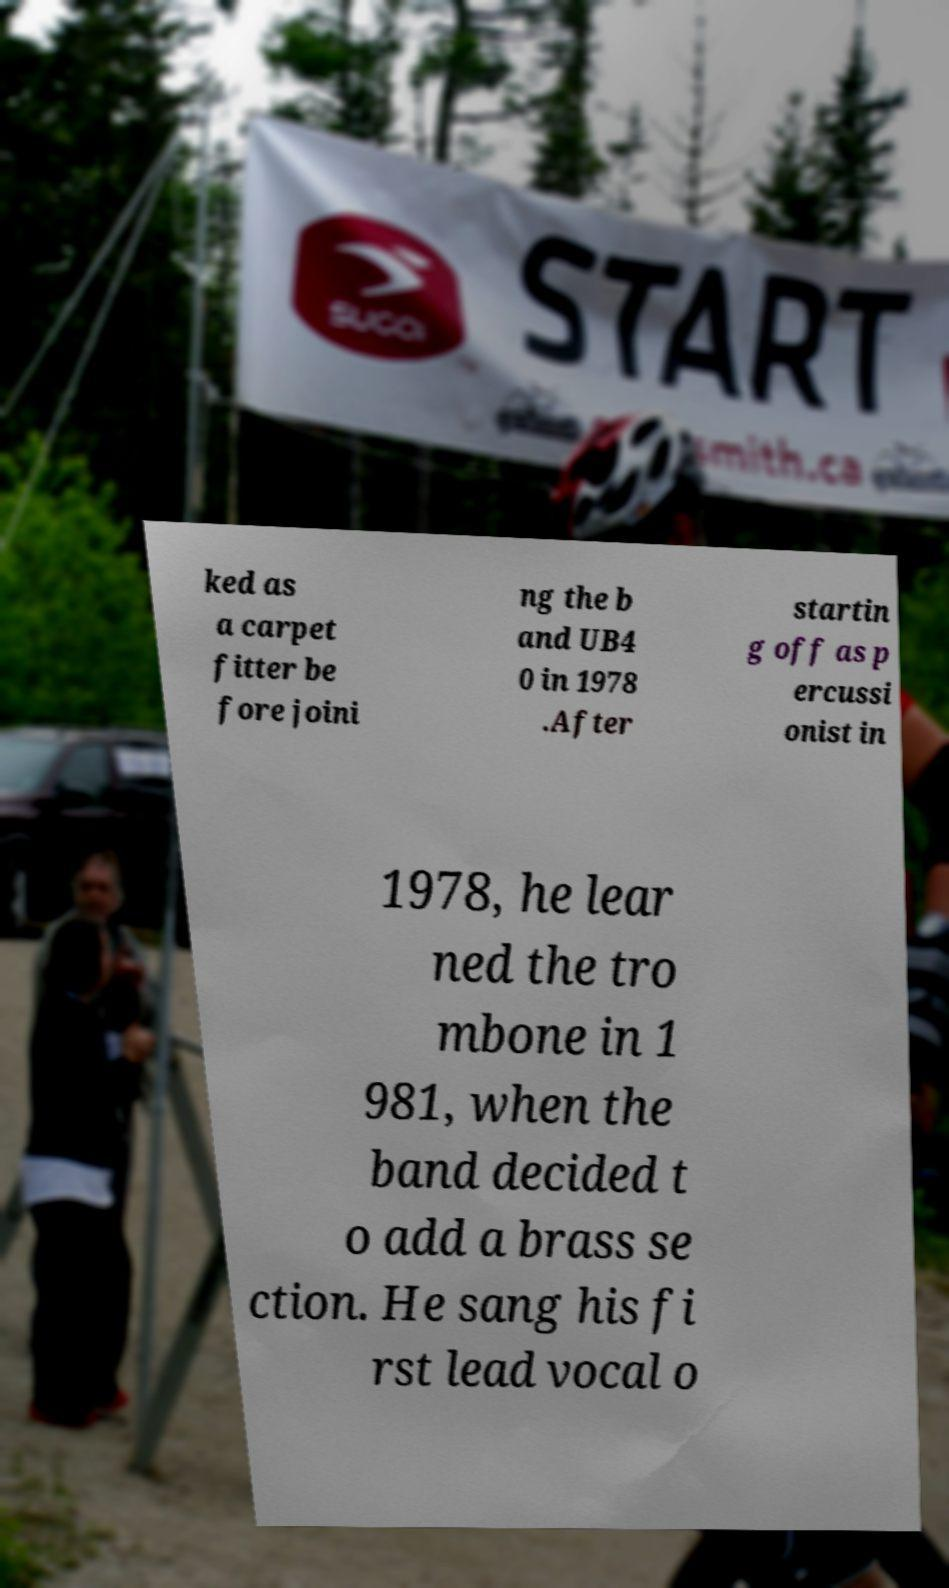There's text embedded in this image that I need extracted. Can you transcribe it verbatim? ked as a carpet fitter be fore joini ng the b and UB4 0 in 1978 .After startin g off as p ercussi onist in 1978, he lear ned the tro mbone in 1 981, when the band decided t o add a brass se ction. He sang his fi rst lead vocal o 